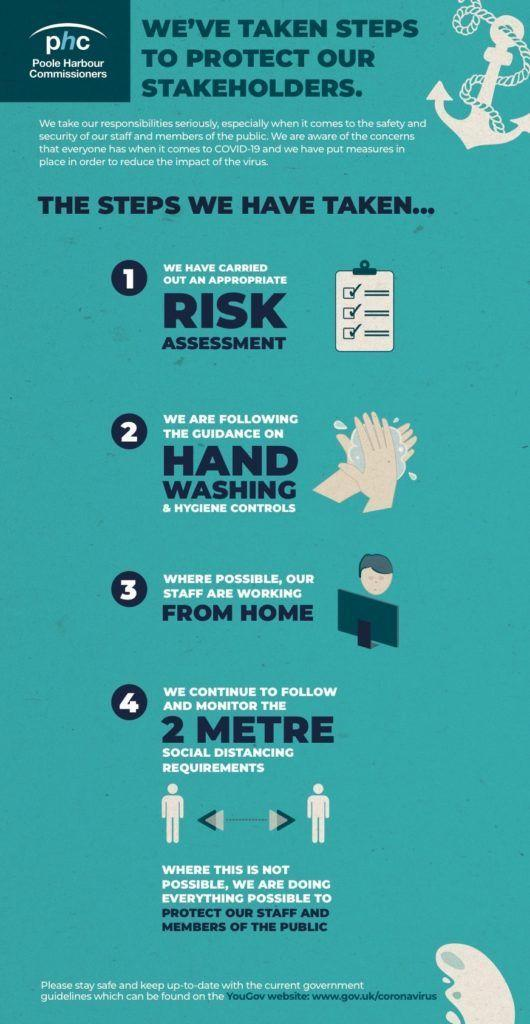Why 'phc' took measures to protect their stakeholders?
Answer the question with a short phrase. to reduce the impact of the virus 'phc' took how many steps to protect their stakeholders? 4 